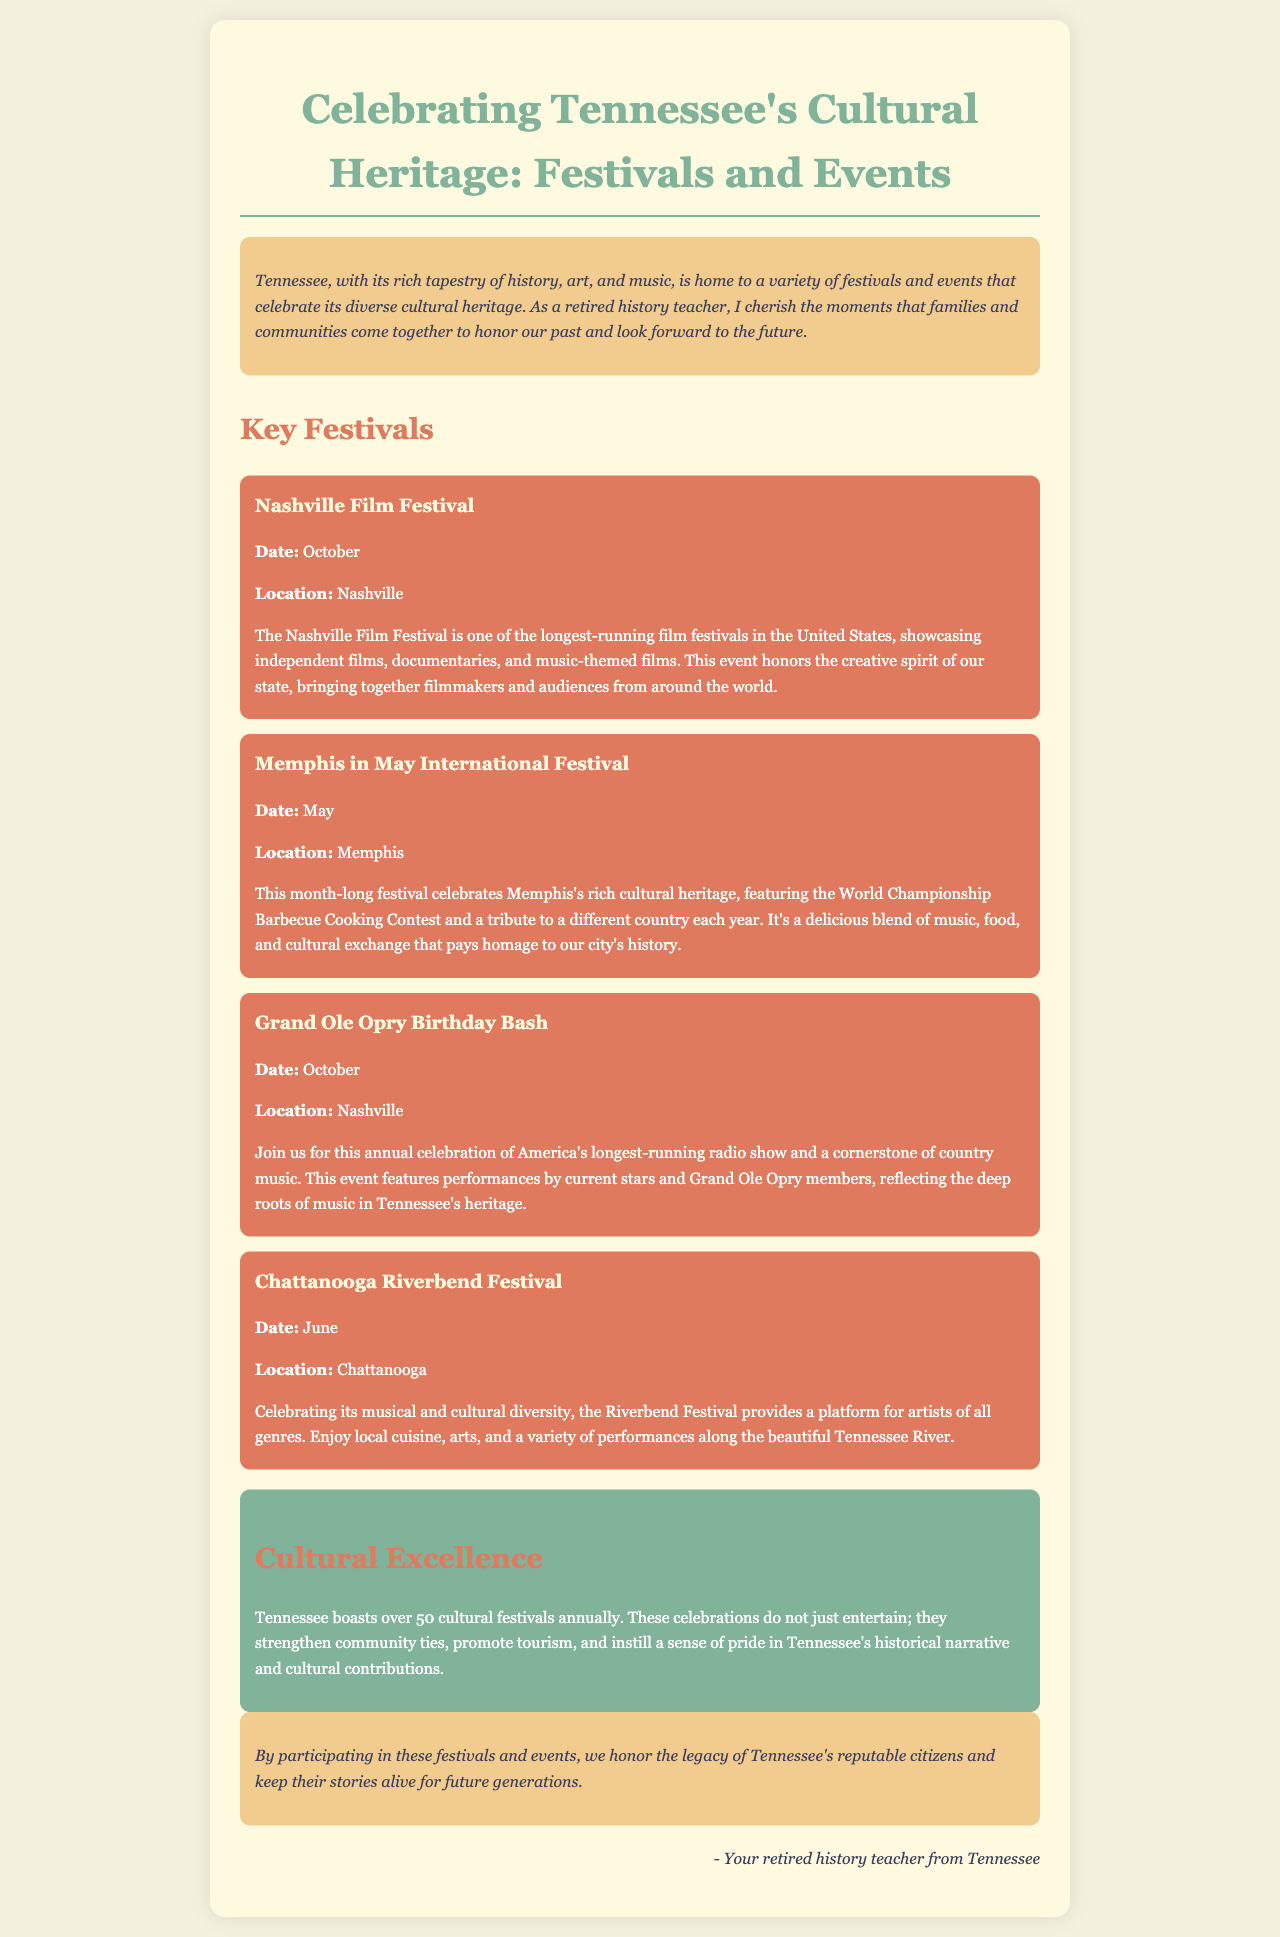What is the title of the brochure? The title of the brochure is provided at the top of the document, highlighting the focus on festivals and events in Tennessee.
Answer: Celebrating Tennessee's Cultural Heritage: Festivals and Events Where is the Nashville Film Festival held? The location of the Nashville Film Festival is stated clearly in the festival section of the brochure.
Answer: Nashville What month does the Grand Ole Opry Birthday Bash occur? The month for the Grand Ole Opry Birthday Bash is specifically mentioned in its festival details.
Answer: October Which festival features a World Championship Barbecue Cooking Contest? The festival that includes this cooking contest is described in the section dedicated to Memphis in May.
Answer: Memphis in May International Festival How many cultural festivals does Tennessee boast annually? This information is mentioned in the cultural impact section, highlighting the significance of the festivals.
Answer: Over 50 What type of music is celebrated at the Grand Ole Opry Birthday Bash? The type of music celebrated at the Grand Ole Opry is mentioned directly in the festival description.
Answer: Country music What does the Riverbend Festival promote? The Riverbend Festival's focus is outlined in its description, showcasing the diversity it celebrates.
Answer: Musical and cultural diversity Who is the author of the brochure? The author is identified in the signature section at the end of the document.
Answer: Your retired history teacher from Tennessee What is the main purpose of the festivals in Tennessee? The purpose is indicated in the cultural impact section, emphasizing their contribution to community.
Answer: Strengthen community ties 